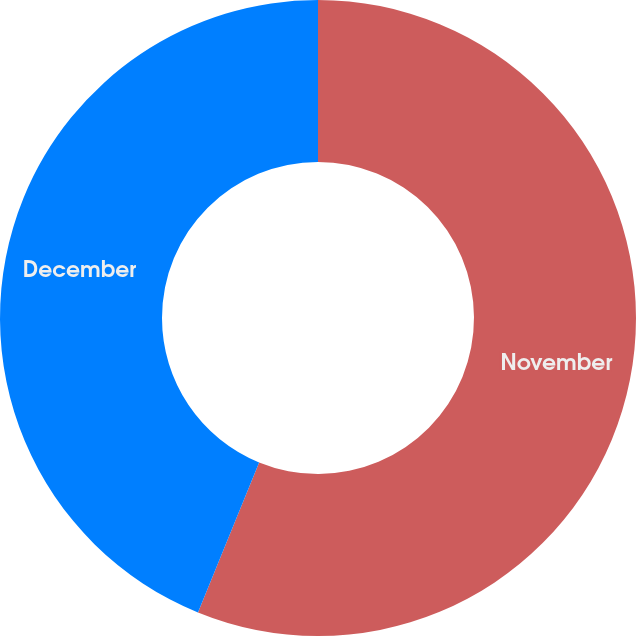Convert chart to OTSL. <chart><loc_0><loc_0><loc_500><loc_500><pie_chart><fcel>November<fcel>December<nl><fcel>56.16%<fcel>43.84%<nl></chart> 